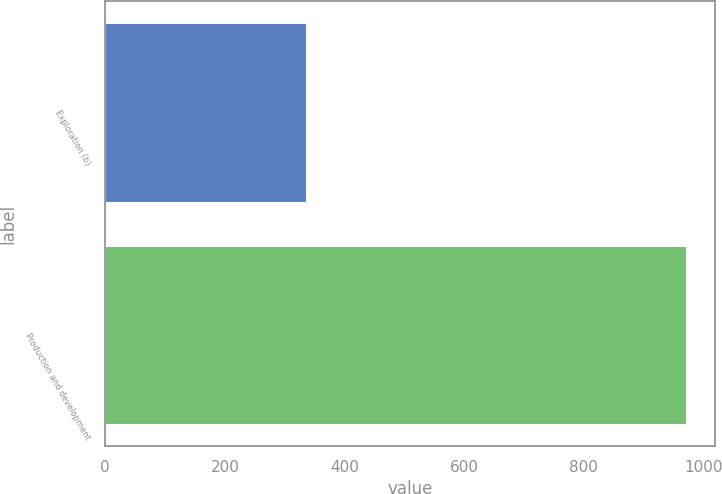Convert chart. <chart><loc_0><loc_0><loc_500><loc_500><bar_chart><fcel>Exploration (b)<fcel>Production and development<nl><fcel>335<fcel>971<nl></chart> 